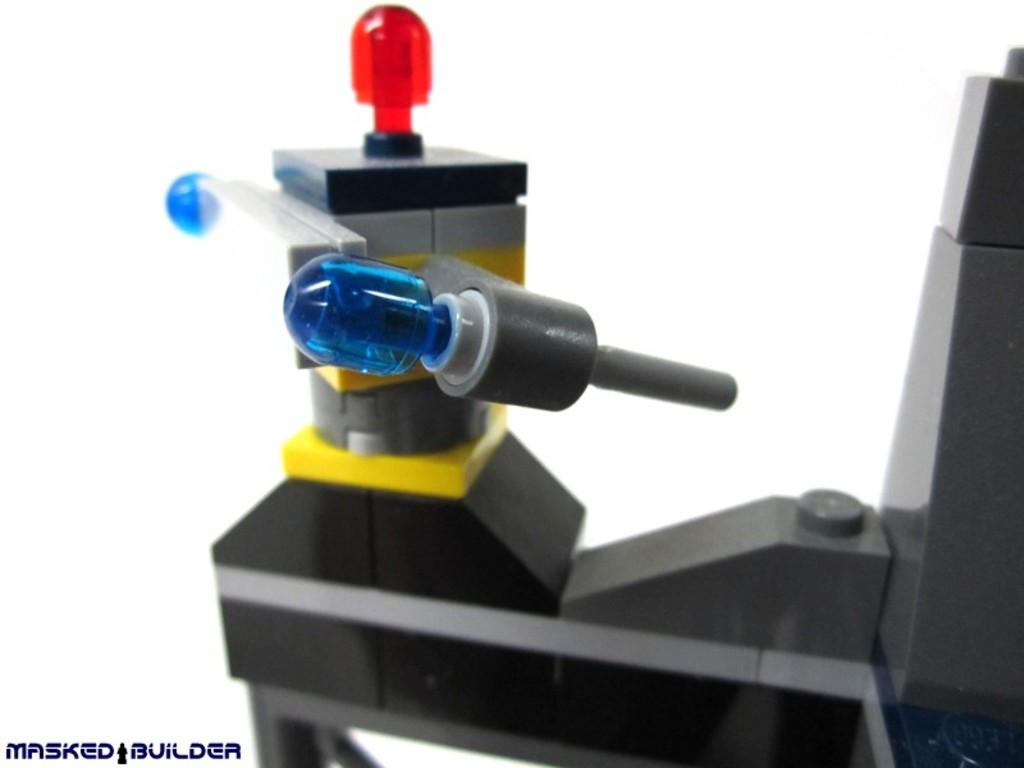What is the main subject of the image? The main subject of the image is a machine tool. What feature does the machine tool have? The machine tool has LED lights. What color is the background of the image? The background of the image is white. Where is the text located in the image? The text is in the left bottom of the image. Can you hear the machine tool cry in the image? There is no sound or indication of crying in the image, as it is a static representation of a machine tool. 